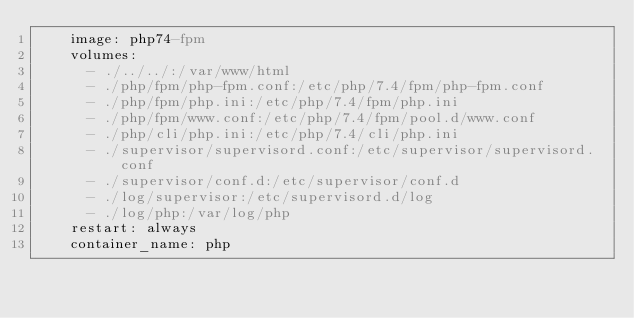<code> <loc_0><loc_0><loc_500><loc_500><_YAML_>    image: php74-fpm
    volumes:
      - ./../../:/var/www/html
      - ./php/fpm/php-fpm.conf:/etc/php/7.4/fpm/php-fpm.conf
      - ./php/fpm/php.ini:/etc/php/7.4/fpm/php.ini
      - ./php/fpm/www.conf:/etc/php/7.4/fpm/pool.d/www.conf
      - ./php/cli/php.ini:/etc/php/7.4/cli/php.ini
      - ./supervisor/supervisord.conf:/etc/supervisor/supervisord.conf
      - ./supervisor/conf.d:/etc/supervisor/conf.d
      - ./log/supervisor:/etc/supervisord.d/log
      - ./log/php:/var/log/php
    restart: always
    container_name: php


</code> 